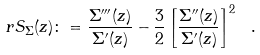<formula> <loc_0><loc_0><loc_500><loc_500>r S _ { \Sigma } ( z ) \colon = \frac { \Sigma ^ { \prime \prime \prime } ( z ) } { \Sigma ^ { \prime } ( z ) } - \frac { 3 } { 2 } \left [ \frac { \Sigma ^ { \prime \prime } ( z ) } { \Sigma ^ { \prime } ( z ) } \right ] ^ { 2 } \ .</formula> 